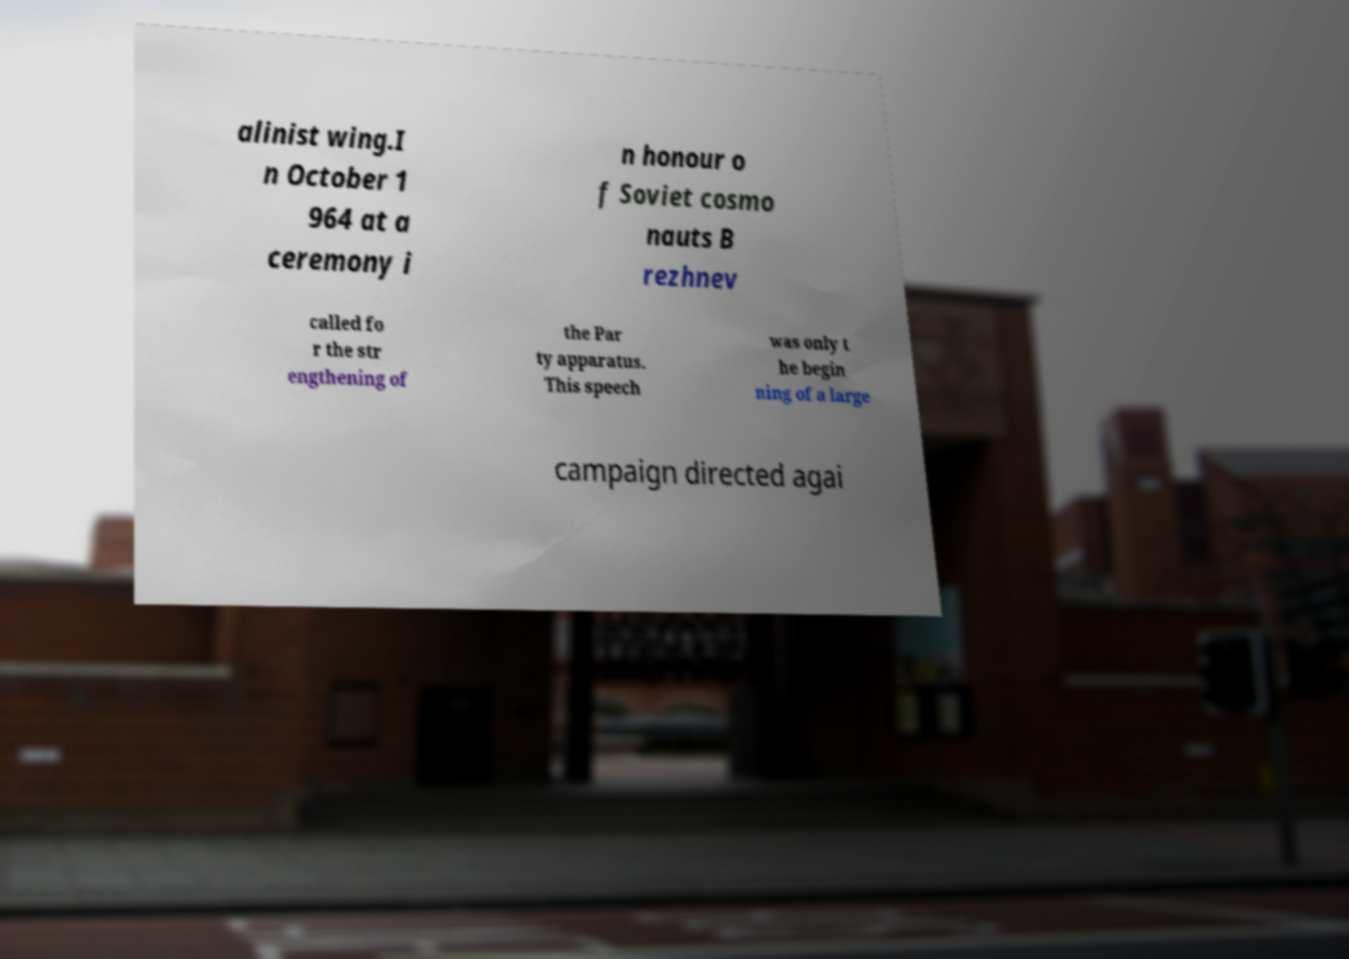Please identify and transcribe the text found in this image. alinist wing.I n October 1 964 at a ceremony i n honour o f Soviet cosmo nauts B rezhnev called fo r the str engthening of the Par ty apparatus. This speech was only t he begin ning of a large campaign directed agai 